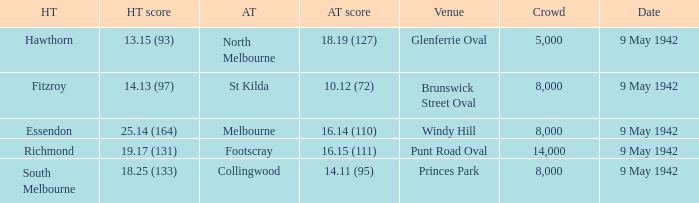How large was the crowd with a home team score of 18.25 (133)? 8000.0. 